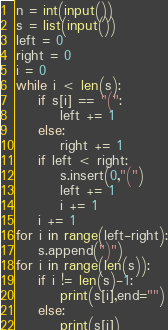<code> <loc_0><loc_0><loc_500><loc_500><_Python_>n = int(input())
s = list(input())
left = 0
right = 0
i = 0
while i < len(s):
    if s[i] == "(":
        left += 1
    else:
        right += 1
    if left < right:
        s.insert(0,"(")
        left += 1
        i += 1
    i += 1
for i in range(left-right):
    s.append(")")
for i in range(len(s)):
    if i != len(s)-1:
        print(s[i],end="")
    else:
        print(s[i])</code> 